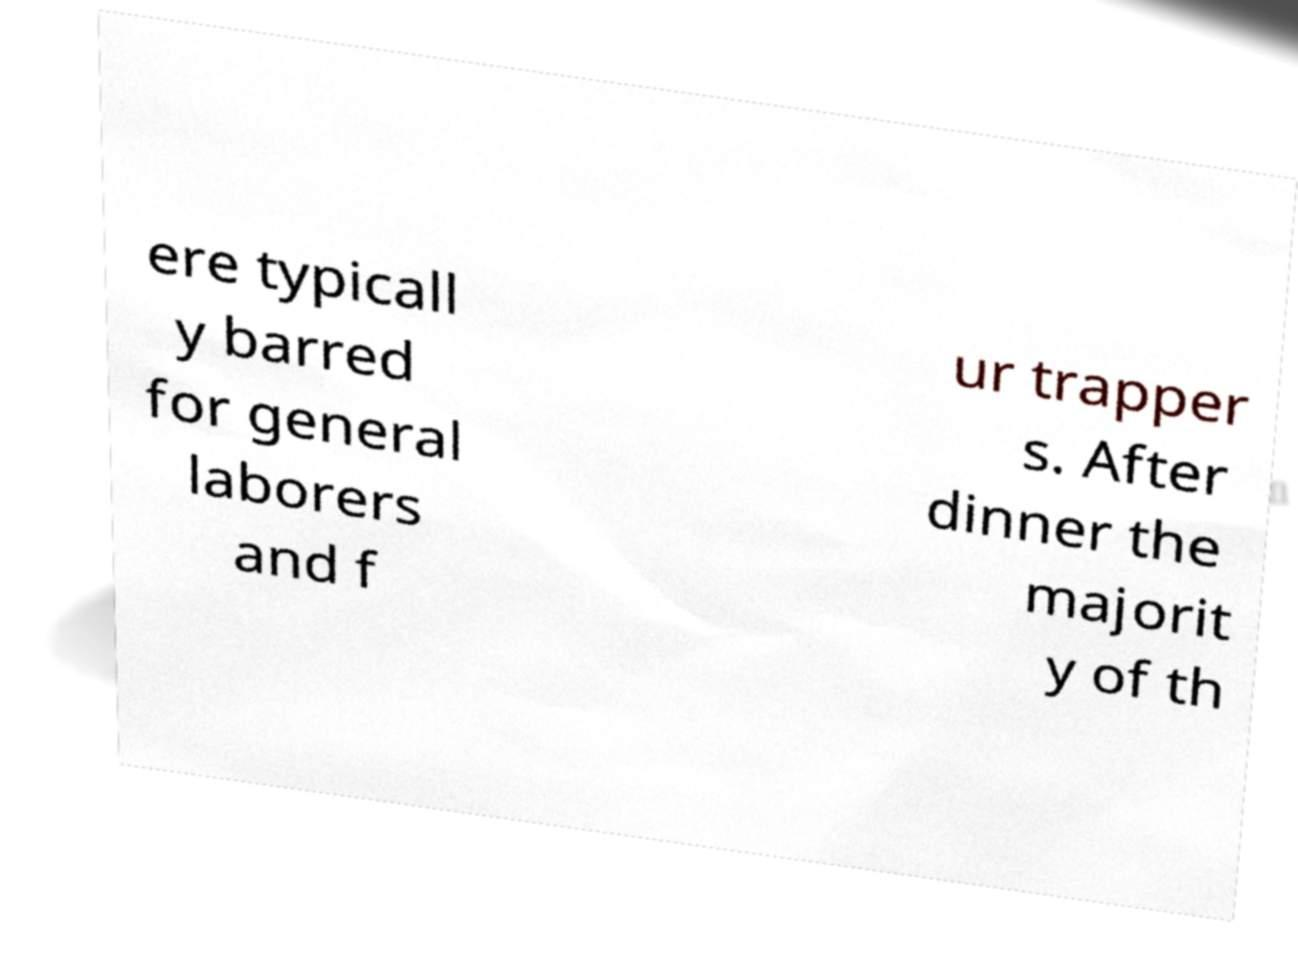Can you accurately transcribe the text from the provided image for me? ere typicall y barred for general laborers and f ur trapper s. After dinner the majorit y of th 